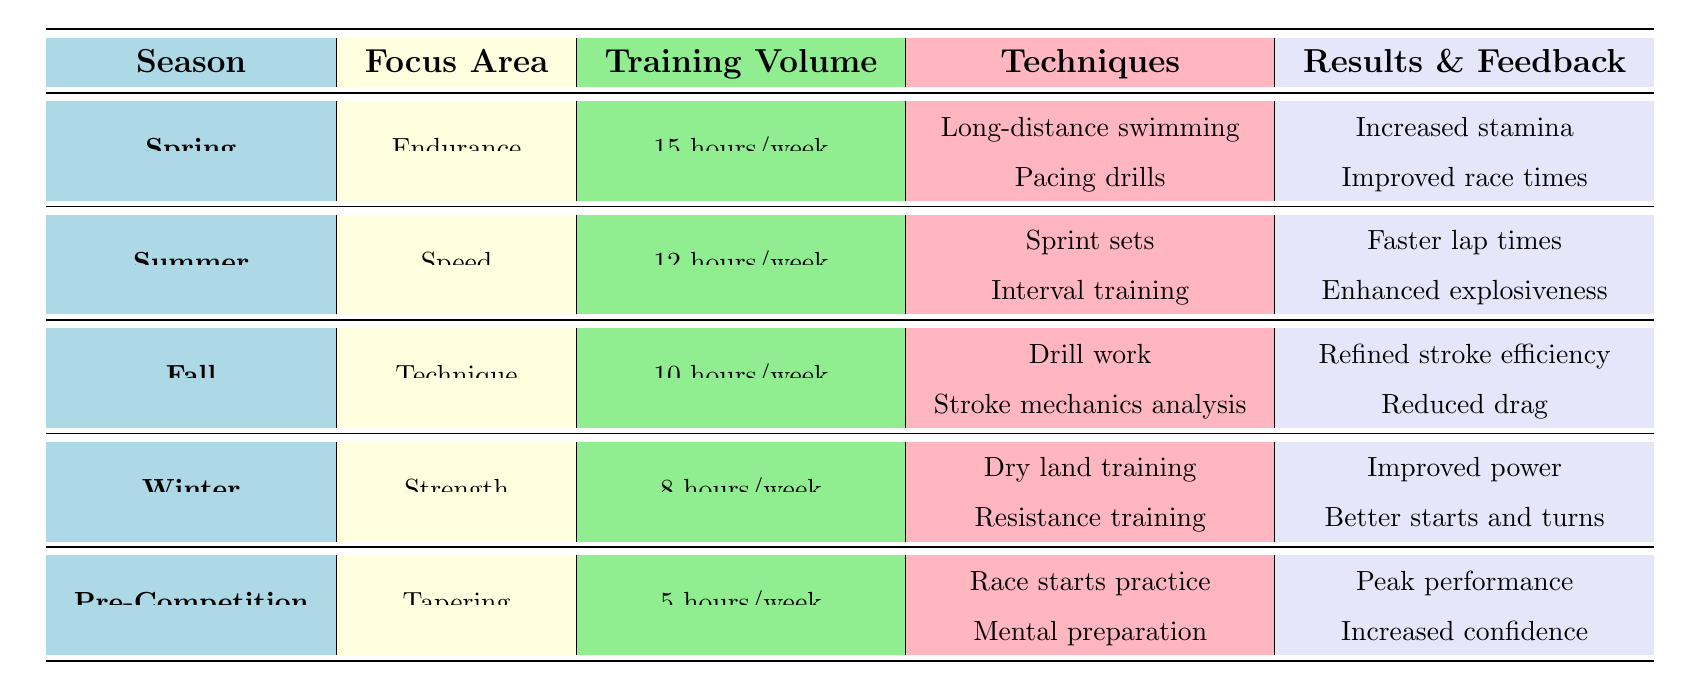What is the training volume for the Fall season? The table shows that for the Fall season, the training volume is listed as "10 hours/week" in the corresponding row.
Answer: 10 hours/week Which focus area has the highest training volume? By examining the training volume column, Spring has the highest volume at "15 hours/week," compared to other seasons.
Answer: Endurance True or False: The Winter season focuses on Technique. The table clearly displays that the focus area for the Winter season is "Strength," not Technique. Therefore, the statement is false.
Answer: False What are the techniques included in the Summer training plan? The Summer training plan includes "Sprint sets" and "Interval training," both of which are listed under the techniques column for this season.
Answer: Sprint sets, Interval training Which focus area has the least amount of training volume and what is that volume? From the table, Winter has the least training volume at "8 hours/week" when compared to the other seasons.
Answer: Strength, 8 hours/week What is the expected outcome of the Pre-Competition training plan? The expected outcome for Pre-Competition training is "Peak performance during competitions" as stated in the expected results column.
Answer: Peak performance during competitions True or False: Athletes reported feeling stronger in the water during Winter training. The athlete feedback for Winter includes that they "felt stronger in the water," confirming the statement is true.
Answer: True What is the difference in training volume between Spring and Winter? The training volume for Spring is "15 hours/week" and for Winter is "8 hours/week." The difference is calculated as 15 - 8 = 7 hours/week.
Answer: 7 hours/week How many hours of training per week are planned for the Endurance focus area during Spring? The table specifies that the training volume for the Endurance focus area in Spring is "15 hours/week," directly available in the row for Spring.
Answer: 15 hours/week 